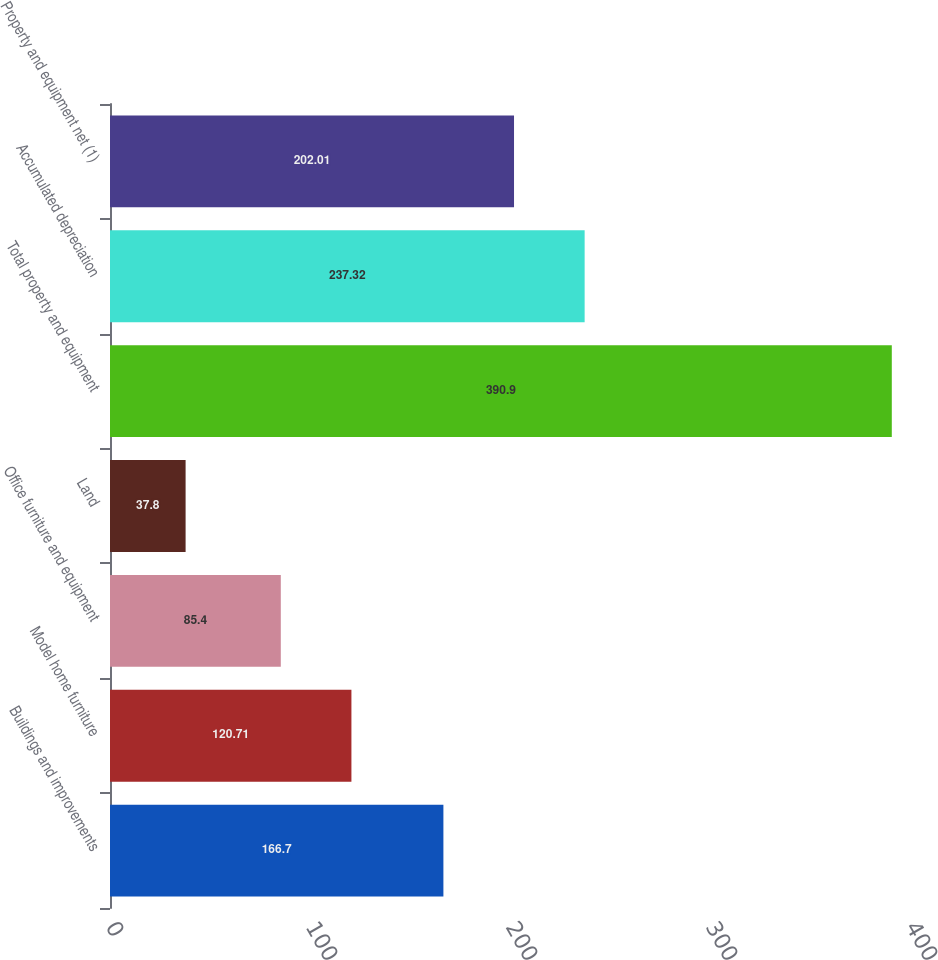<chart> <loc_0><loc_0><loc_500><loc_500><bar_chart><fcel>Buildings and improvements<fcel>Model home furniture<fcel>Office furniture and equipment<fcel>Land<fcel>Total property and equipment<fcel>Accumulated depreciation<fcel>Property and equipment net (1)<nl><fcel>166.7<fcel>120.71<fcel>85.4<fcel>37.8<fcel>390.9<fcel>237.32<fcel>202.01<nl></chart> 